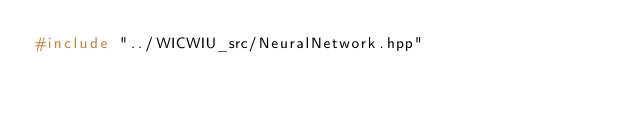<code> <loc_0><loc_0><loc_500><loc_500><_C++_>#include "../WICWIU_src/NeuralNetwork.hpp"</code> 